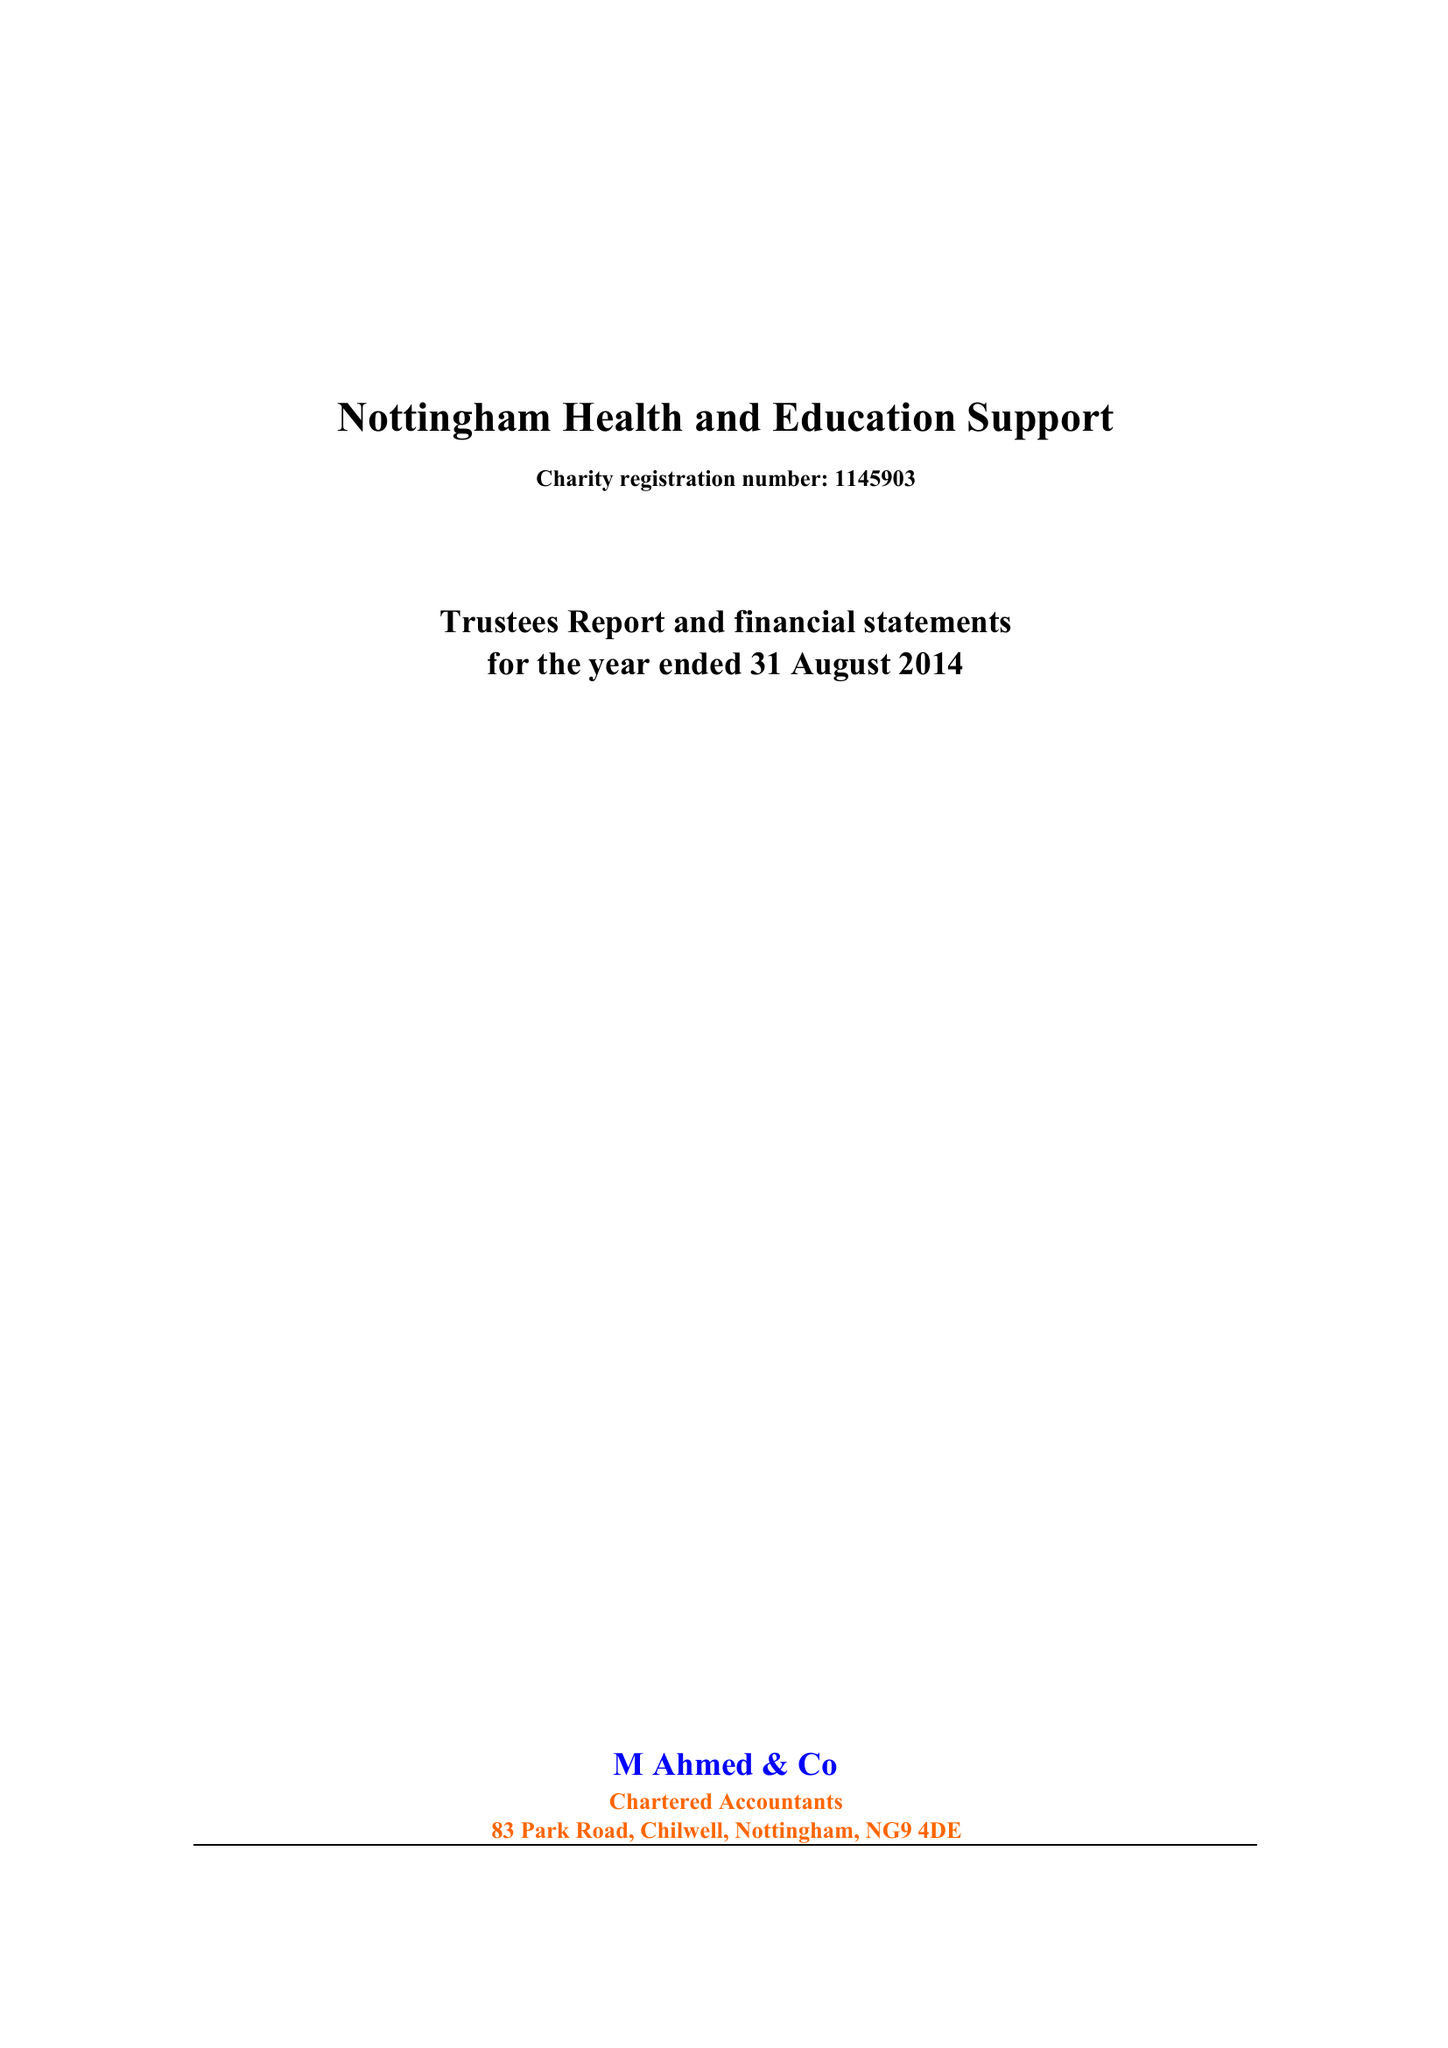What is the value for the address__postcode?
Answer the question using a single word or phrase. NG3 6JX 